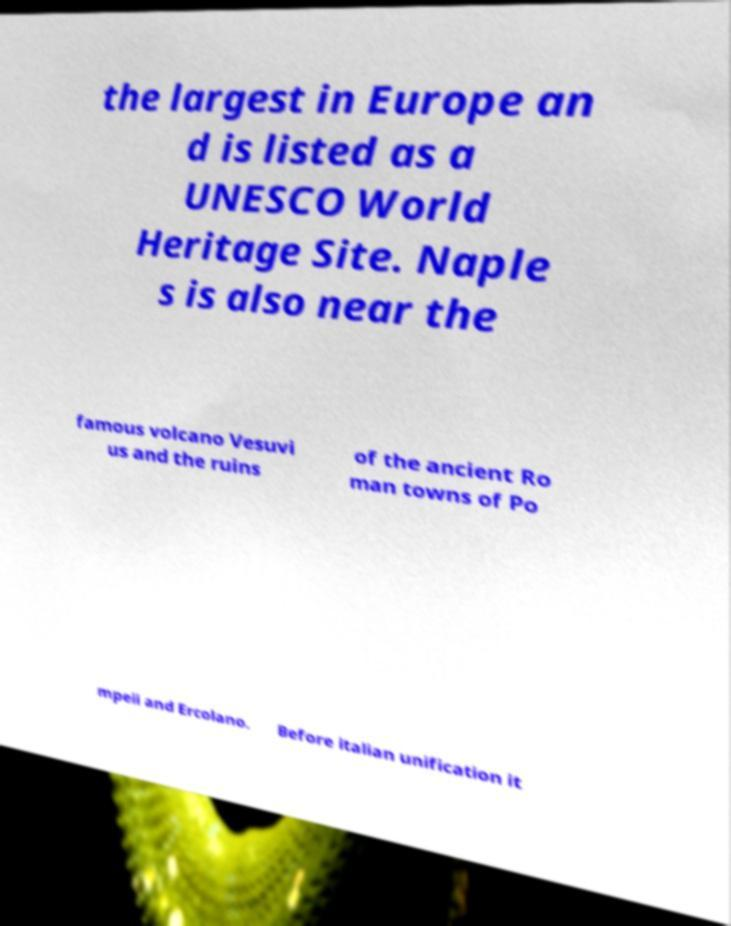For documentation purposes, I need the text within this image transcribed. Could you provide that? the largest in Europe an d is listed as a UNESCO World Heritage Site. Naple s is also near the famous volcano Vesuvi us and the ruins of the ancient Ro man towns of Po mpeii and Ercolano. Before italian unification it 